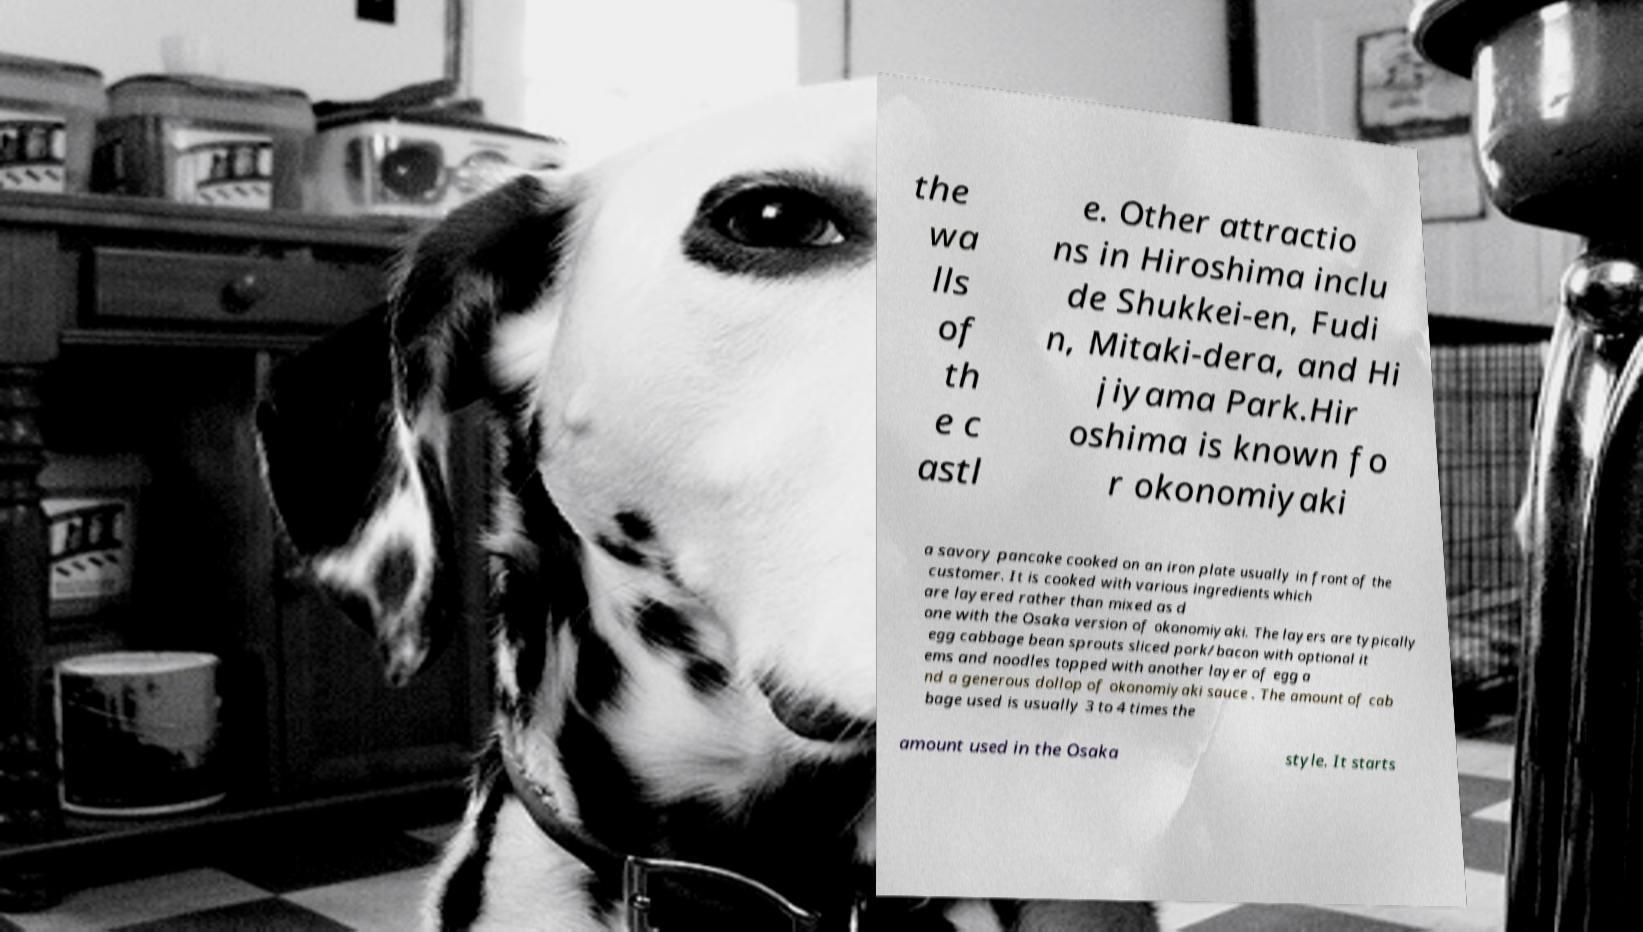Could you assist in decoding the text presented in this image and type it out clearly? the wa lls of th e c astl e. Other attractio ns in Hiroshima inclu de Shukkei-en, Fudi n, Mitaki-dera, and Hi jiyama Park.Hir oshima is known fo r okonomiyaki a savory pancake cooked on an iron plate usually in front of the customer. It is cooked with various ingredients which are layered rather than mixed as d one with the Osaka version of okonomiyaki. The layers are typically egg cabbage bean sprouts sliced pork/bacon with optional it ems and noodles topped with another layer of egg a nd a generous dollop of okonomiyaki sauce . The amount of cab bage used is usually 3 to 4 times the amount used in the Osaka style. It starts 